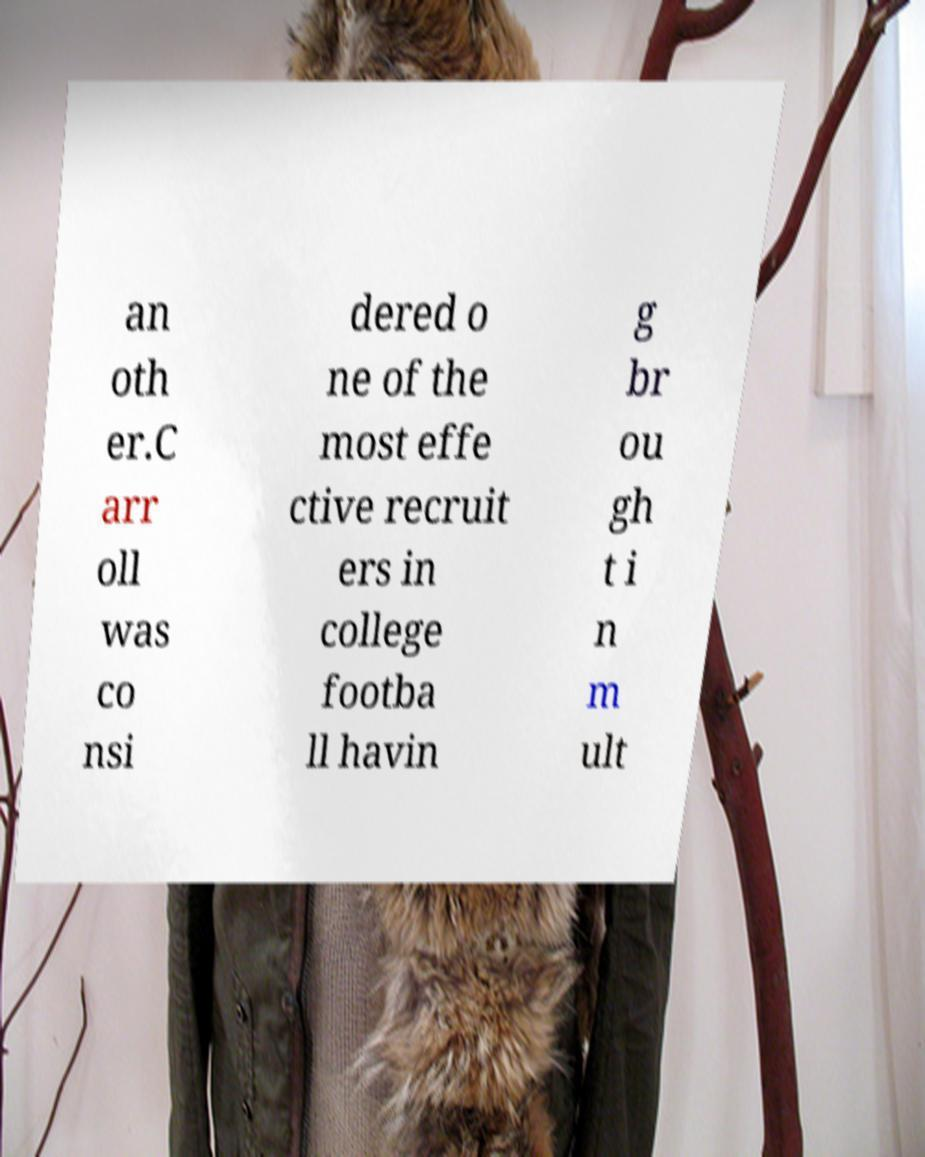I need the written content from this picture converted into text. Can you do that? an oth er.C arr oll was co nsi dered o ne of the most effe ctive recruit ers in college footba ll havin g br ou gh t i n m ult 